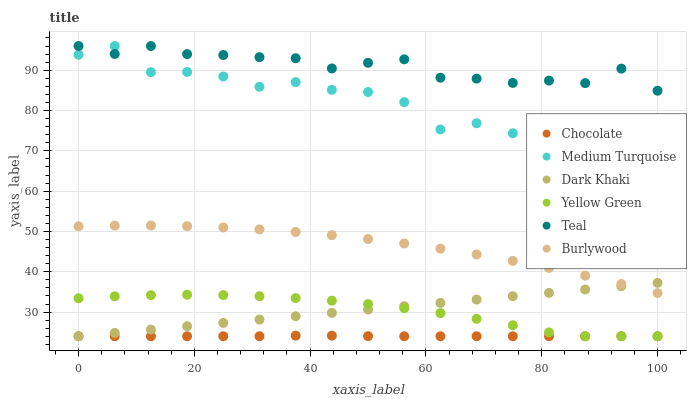Does Chocolate have the minimum area under the curve?
Answer yes or no. Yes. Does Teal have the maximum area under the curve?
Answer yes or no. Yes. Does Yellow Green have the minimum area under the curve?
Answer yes or no. No. Does Yellow Green have the maximum area under the curve?
Answer yes or no. No. Is Dark Khaki the smoothest?
Answer yes or no. Yes. Is Medium Turquoise the roughest?
Answer yes or no. Yes. Is Yellow Green the smoothest?
Answer yes or no. No. Is Yellow Green the roughest?
Answer yes or no. No. Does Yellow Green have the lowest value?
Answer yes or no. Yes. Does Burlywood have the lowest value?
Answer yes or no. No. Does Teal have the highest value?
Answer yes or no. Yes. Does Yellow Green have the highest value?
Answer yes or no. No. Is Yellow Green less than Medium Turquoise?
Answer yes or no. Yes. Is Medium Turquoise greater than Burlywood?
Answer yes or no. Yes. Does Dark Khaki intersect Burlywood?
Answer yes or no. Yes. Is Dark Khaki less than Burlywood?
Answer yes or no. No. Is Dark Khaki greater than Burlywood?
Answer yes or no. No. Does Yellow Green intersect Medium Turquoise?
Answer yes or no. No. 